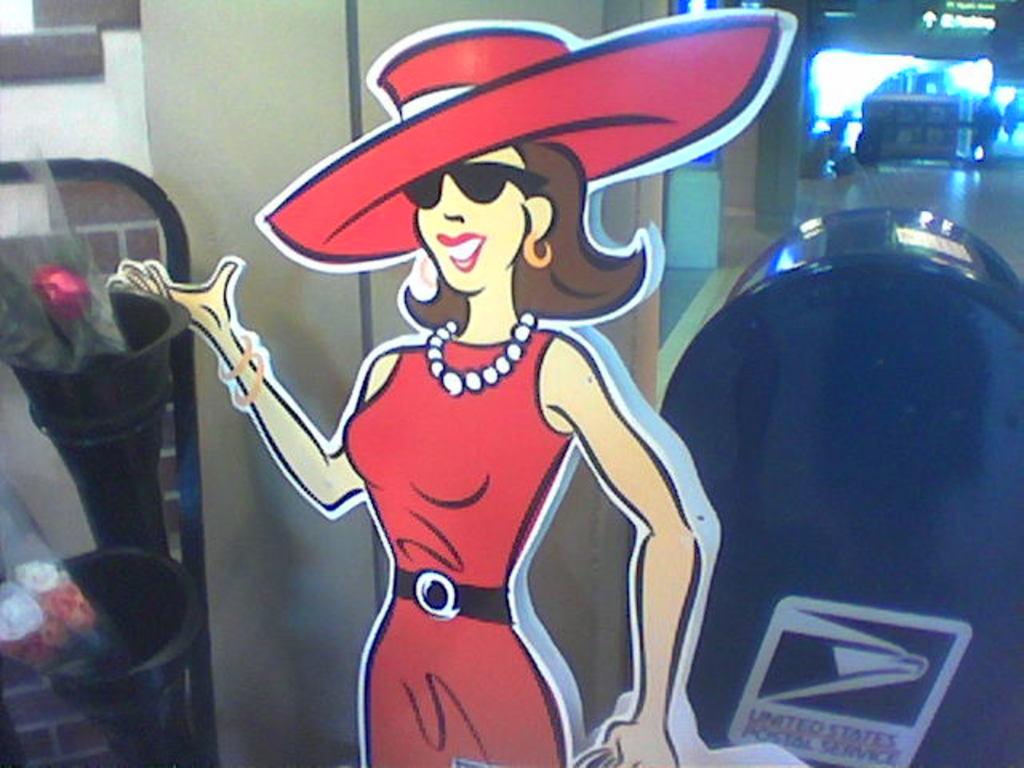What government company is written behind the poster of the woman?
Make the answer very short. United states postal service. 